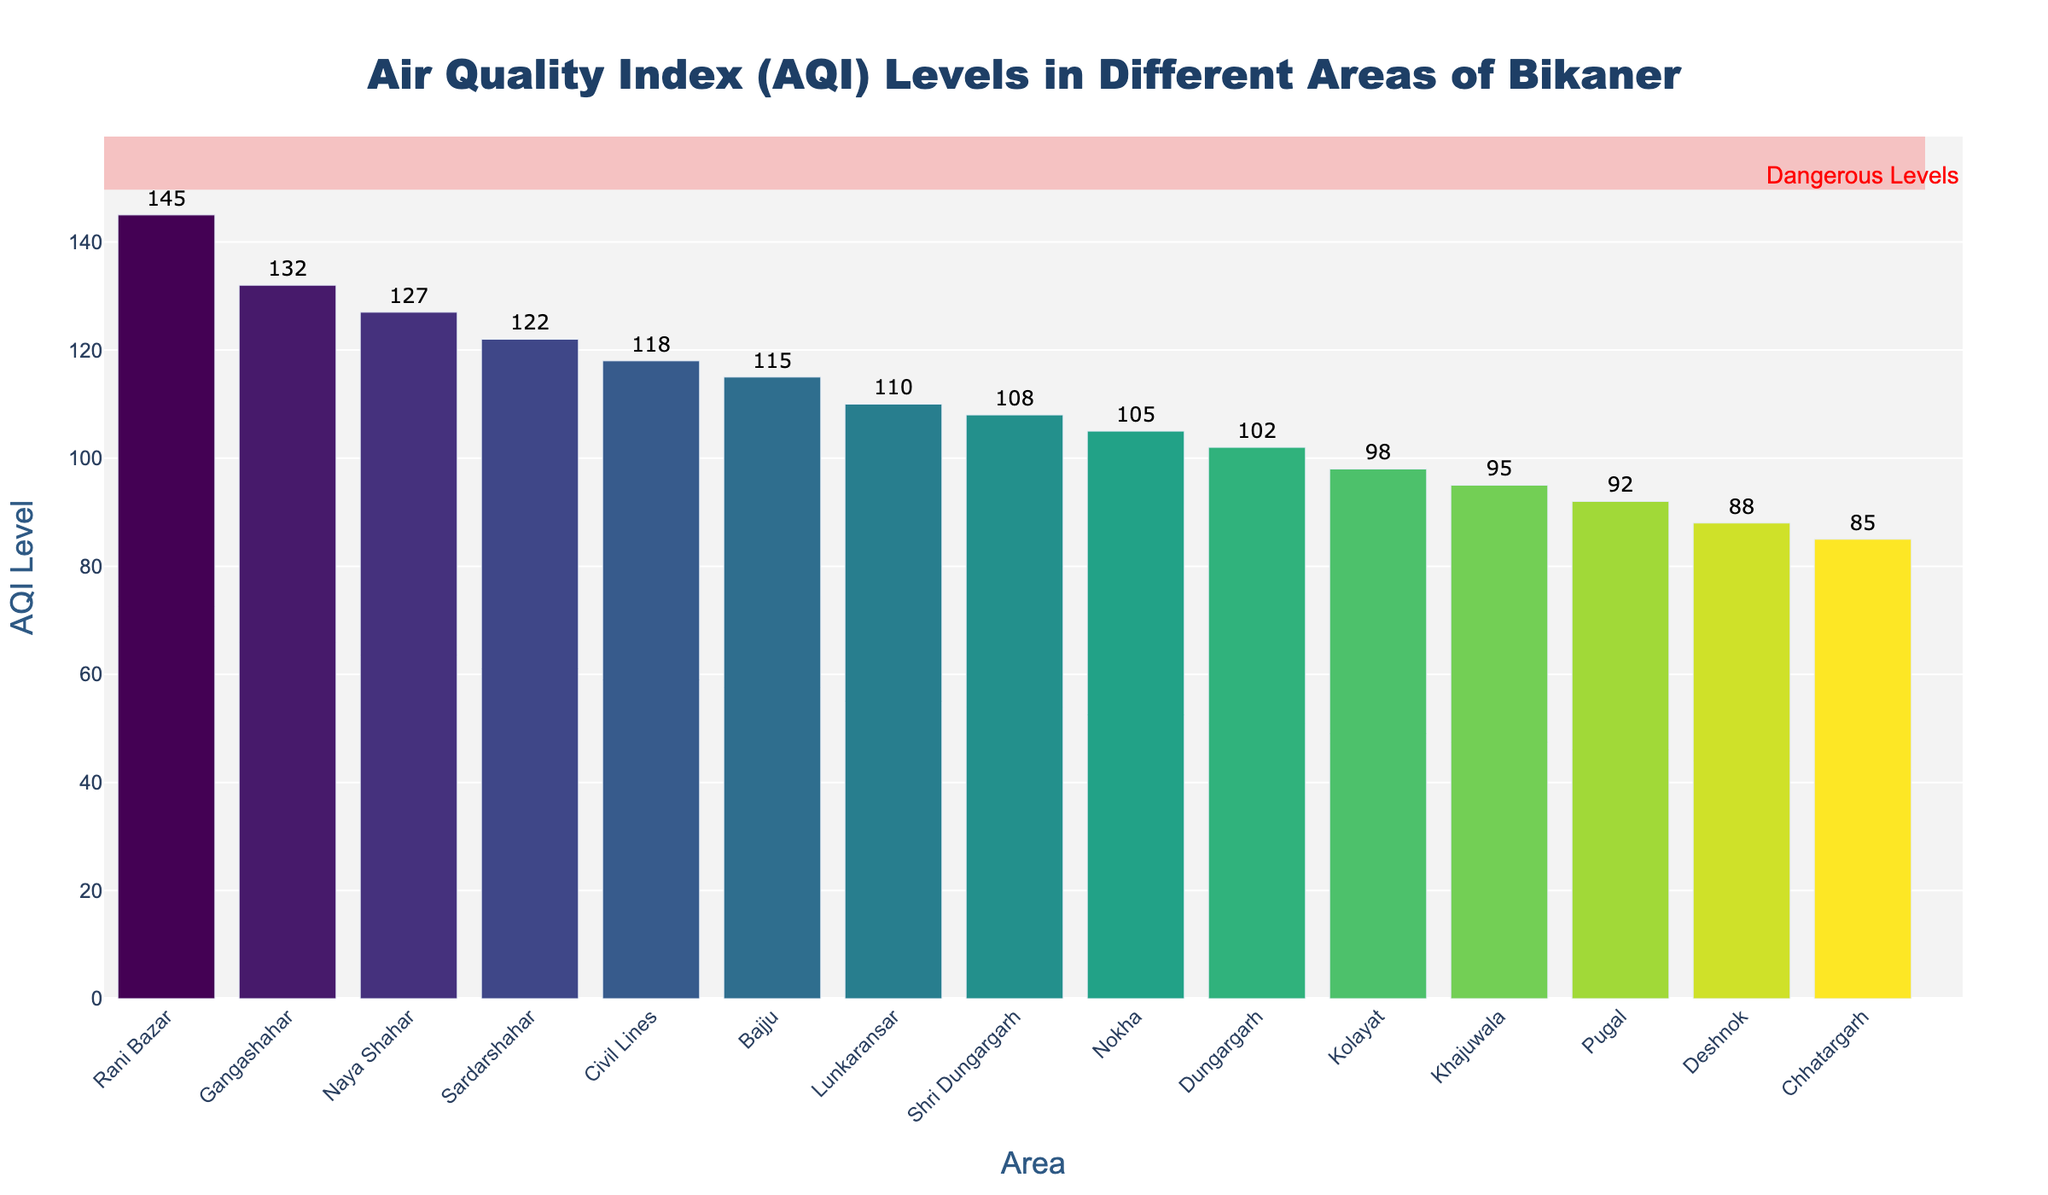What is the highest AQI level among the areas in Bikaner? The Civil Lines area has the highest AQI level of 145. This is determined by examining the top bar in the sorted bar chart.
Answer: 145 Which area has the lowest AQI level? The Chhatargarh area has the lowest AQI level with a value of 85, as seen from the shortest bar in the chart.
Answer: 85 How many areas have an AQI level above 120? The areas with AQI levels above 120 are Gangashahar (132), Rani Bazar (145), Naya Shahar (127), and Sardarshahar (122). Counting these, we have four areas in total.
Answer: 4 What is the difference in AQI levels between the area with the highest AQI and the area with the lowest AQI? The highest AQI level is 145 (Rani Bazar) and the lowest is 85 (Chhatargarh). The difference is calculated as 145 - 85 = 60.
Answer: 60 What is the average AQI level of the areas displayed? First, sum the AQI levels of all areas: 118 + 132 + 145 + 127 + 95 + 105 + 88 + 92 + 110 + 98 + 115 + 102 + 85 + 108 + 122 = 1642. Then divide by the number of areas, 15, to get the average AQI level: 1642 / 15 = 109.47.
Answer: 109.47 Which areas have AQI levels between 100 and 120? The areas with AQI levels between 100 and 120 are Civil Lines (118), Lunkaransar (110), Bajju (115), Shri Dungargarh (108), and Dungargarh (102).
Answer: Civil Lines, Lunkaransar, Bajju, Shri Dungargarh, Dungargarh Is there any area with an AQI level considered dangerous, marked in the red shaded region? The red shaded region marks AQI levels at or above 150. No area exceeds this threshold in the chart, as the highest AQI level is 145.
Answer: No Compare the AQI levels of Naya Shahar and Kolayat. Which area has higher pollution levels? Naya Shahar has an AQI level of 127, while Kolayat has an AQI level of 98. Since 127 is greater than 98, Naya Shahar has higher pollution levels.
Answer: Naya Shahar What is the median AQI level of all areas? To find the median, list the AQI levels in ascending order: 85, 88, 92, 95, 98, 102, 105, 108, 110, 115, 118, 122, 127, 132, 145. The median value, being the middle value in this ordered list, is the 8th value, which is 110.
Answer: 110 